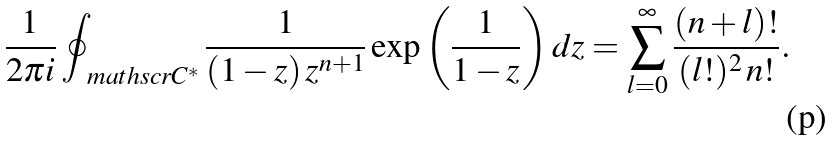<formula> <loc_0><loc_0><loc_500><loc_500>\frac { 1 } { 2 \pi i } \oint _ { \ m a t h s c r { C ^ { \ast } } } \frac { 1 } { ( 1 - z ) \, z ^ { n + 1 } } \exp \left ( \frac { 1 } { 1 - z } \right ) d z = \sum _ { l = 0 } ^ { \infty } \frac { ( n + l ) ! } { ( l ! ) ^ { 2 } \, n ! } .</formula> 